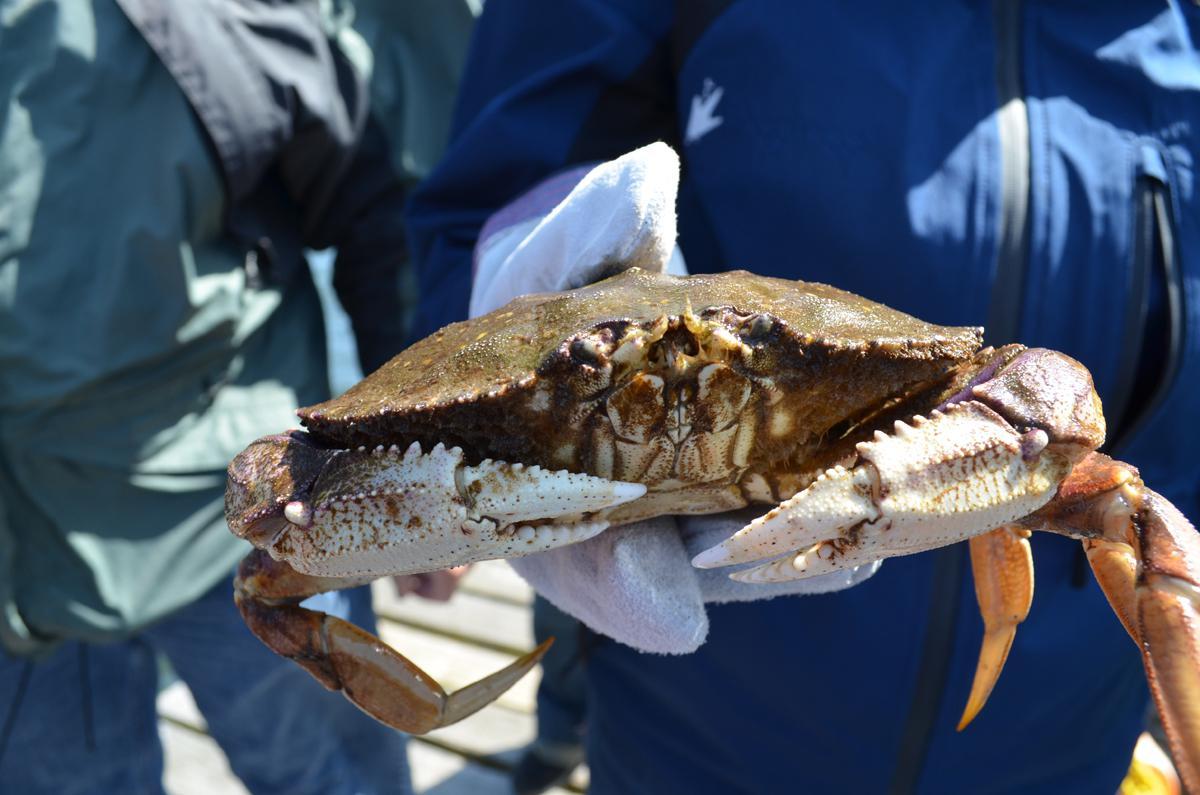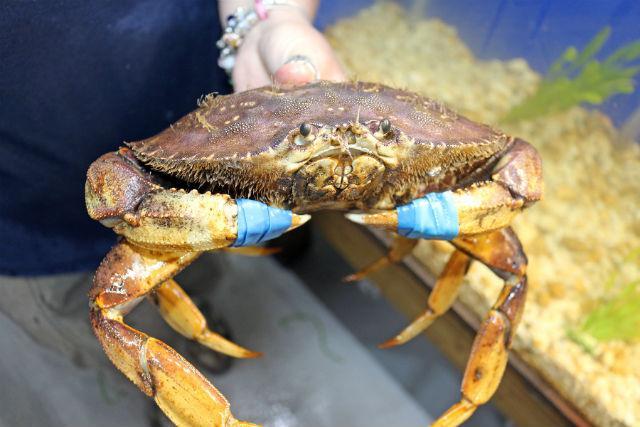The first image is the image on the left, the second image is the image on the right. For the images shown, is this caption "A crab is being held vertically." true? Answer yes or no. No. The first image is the image on the left, the second image is the image on the right. Assess this claim about the two images: "An image shows one bare hand with the thumb on the right holding up a belly-first, head-up crab, with water in the background.". Correct or not? Answer yes or no. No. 